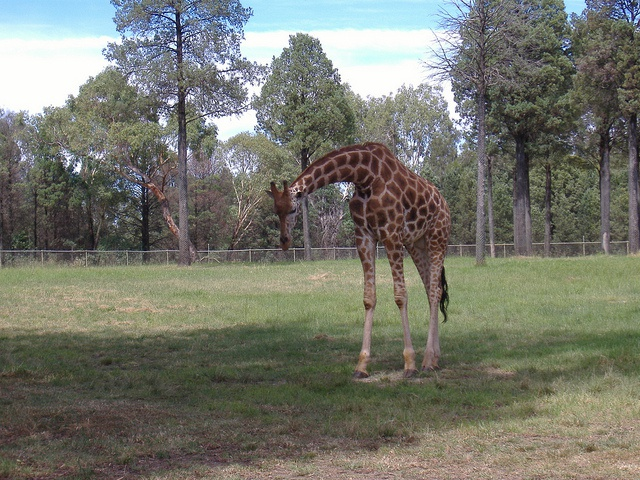Describe the objects in this image and their specific colors. I can see a giraffe in lightblue, gray, maroon, and black tones in this image. 